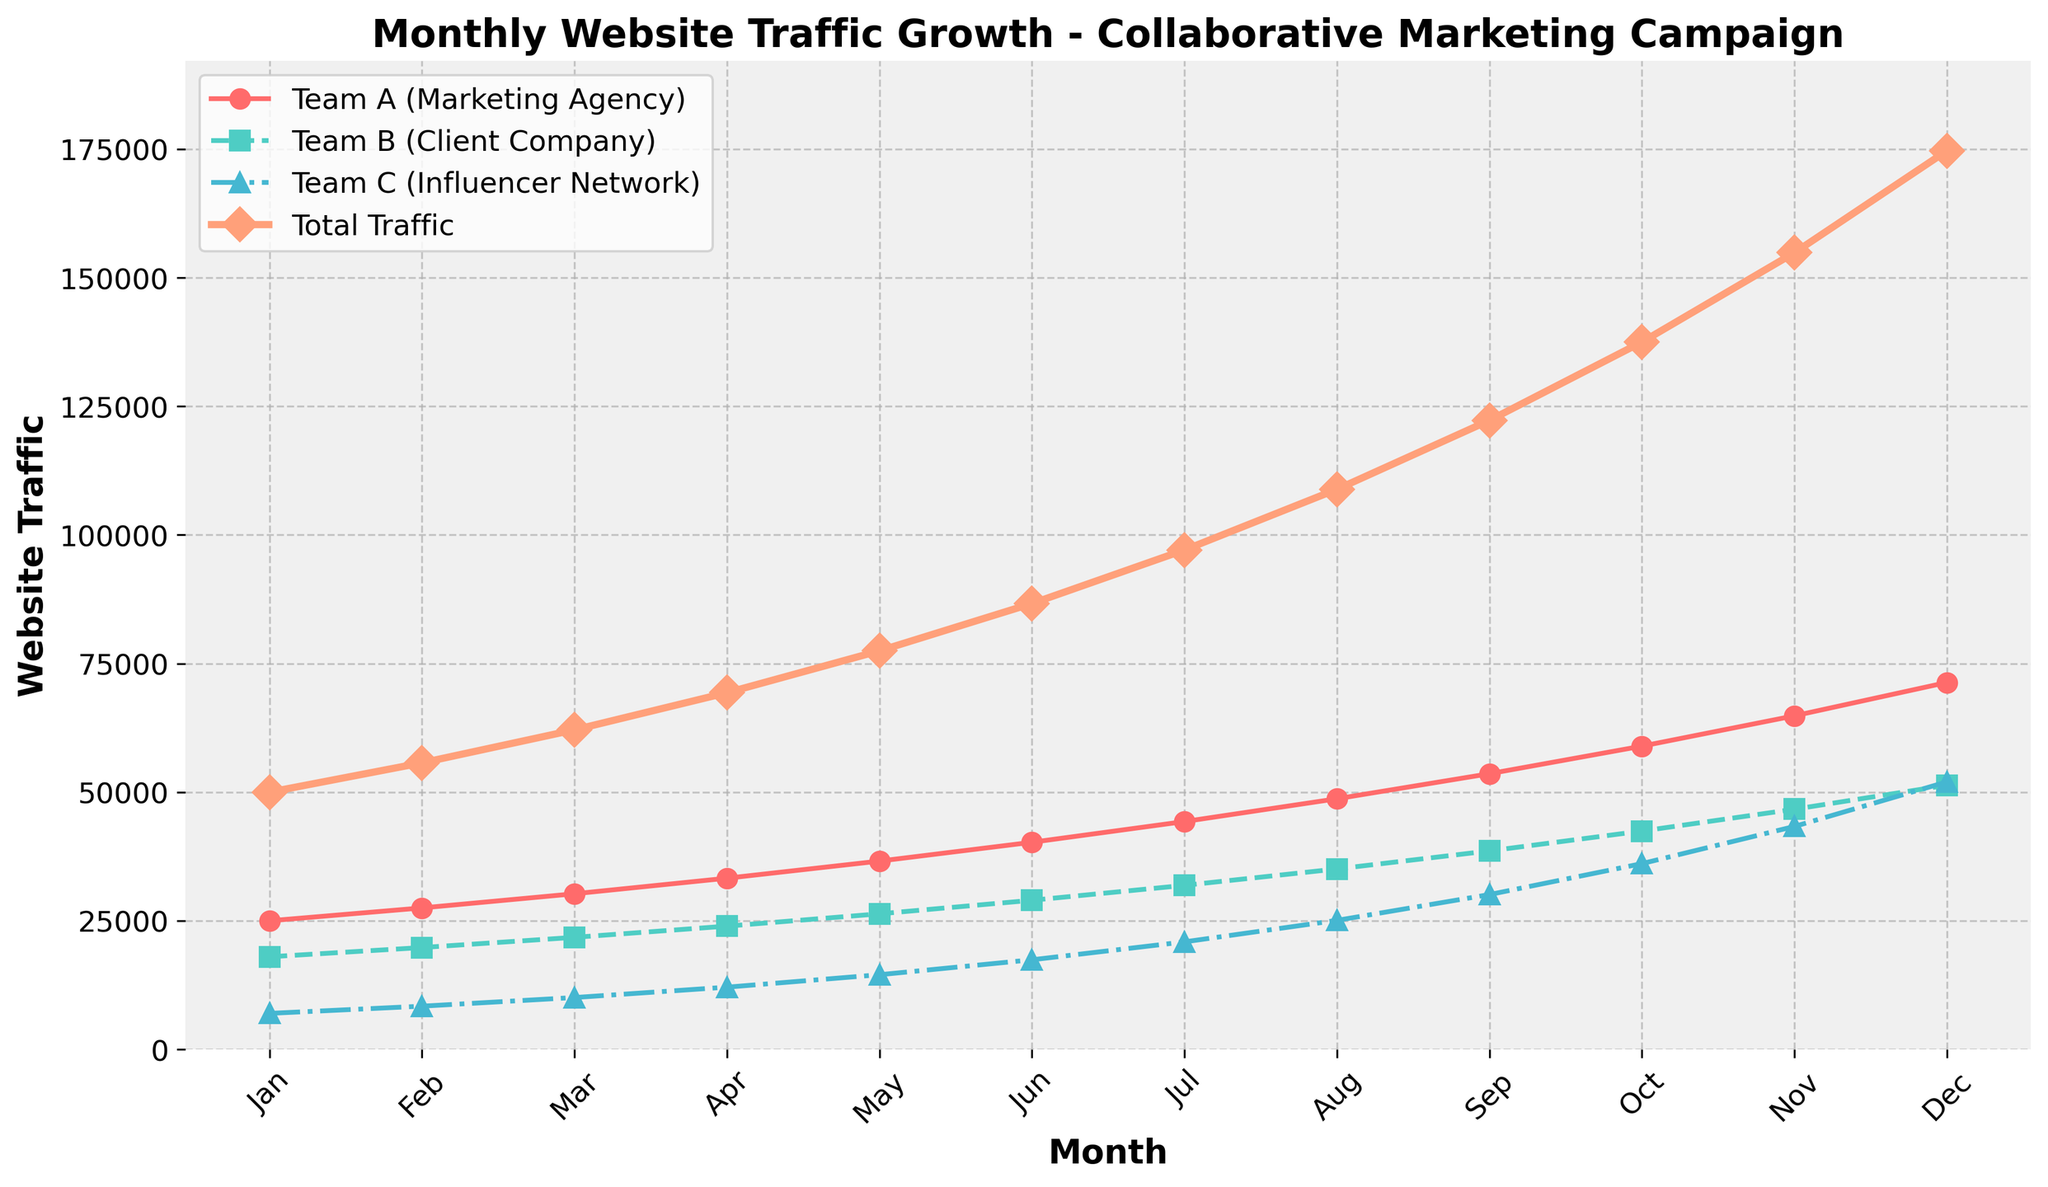what month did Team C (Influencer Network) first exceed 10,000 website traffic? Identify when Team C's traffic crosses 10,000 by looking at Team C's line. The line crosses 10,000 between February and March.
Answer: March Which team experienced the most consistent growth over the year? Examine the steepness and smoothness of each line. Team A shows a consistent, steady incline compared to other teams.
Answer: Team A In which month did the total website traffic first exceed 100,000? Check when the total traffic line crosses the 100,000 mark. This occurs between July and August.
Answer: August What was the traffic for Team B (Client Company) in July? Locate July along the x-axis and trace up to the Team B line marked by 'squares'. The point corresponding to July is approximately 31,887.
Answer: 31,887 In which month did Team A (Marketing Agency) surpass 50,000 website traffic? Track Team A's (red line) progression until it crosses the 50,000 mark, which occurs between August and September.
Answer: September Compare the traffic growth between Team B (Client Company) and Team C (Influencer Network) from February to March. Which team had a higher percentage increase? Calculate the percentage increase for both teams: Team B - (21780-19800)/19800 ≈ 10%, Team C - (10080-8400)/8400 ≈ 20%.
Answer: Team C Which team ends the year with the highest website traffic and what is the traffic amount? Compare the final points of all teams in December. Team A's point is the highest at approximately 71,326.
Answer: Team A, 71,326 By how much did Team A (Marketing Agency) increase its traffic from January to December? Subtract January's traffic from December's traffic for Team A. 71326 - 25000 = 46,326.
Answer: 46,326 What is the average traffic for Team C (Influencer Network) across the year? Sum Team C's monthly traffic and divide by 12. Sum is 22,388/12 ≈ 14,786.
Answer: 14,786 Compare the total yearly traffic of Team A and Team B. Which team had a higher total? Sum Team A and Team B monthly traffic and compare. Team A: 447,973, Team B: 385,900. Team A has higher traffic.
Answer: Team A 